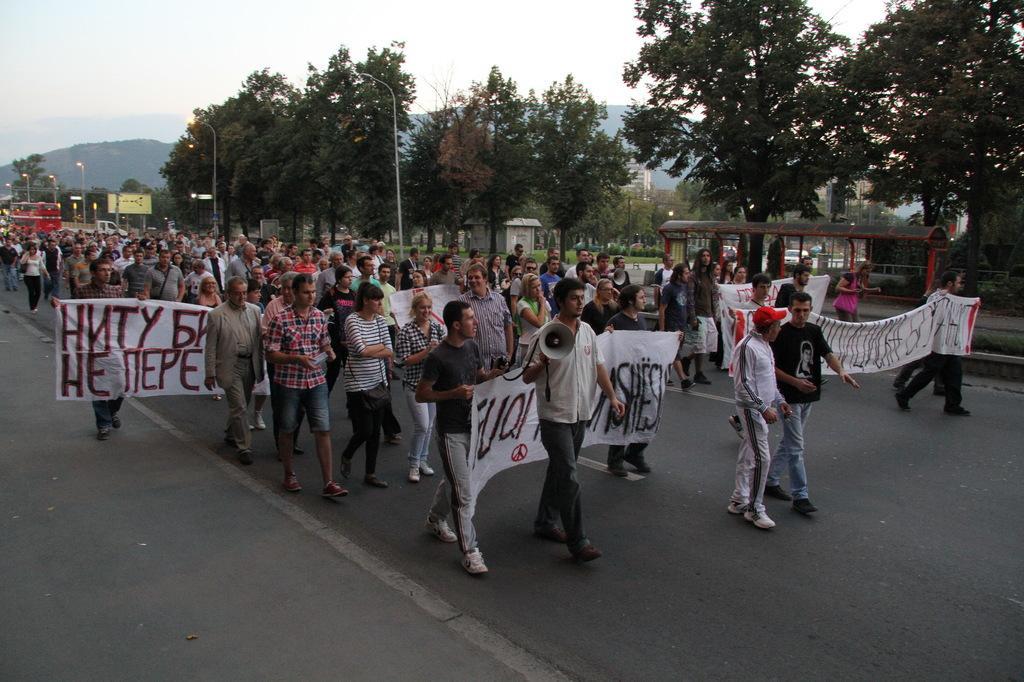Describe this image in one or two sentences. In the image we can see there are lot of people standing on the road and they are holding cloth banners in their hands. A man is holding a megaphone in his hand. 